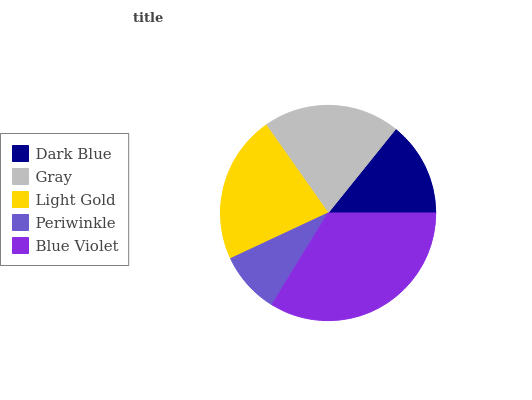Is Periwinkle the minimum?
Answer yes or no. Yes. Is Blue Violet the maximum?
Answer yes or no. Yes. Is Gray the minimum?
Answer yes or no. No. Is Gray the maximum?
Answer yes or no. No. Is Gray greater than Dark Blue?
Answer yes or no. Yes. Is Dark Blue less than Gray?
Answer yes or no. Yes. Is Dark Blue greater than Gray?
Answer yes or no. No. Is Gray less than Dark Blue?
Answer yes or no. No. Is Gray the high median?
Answer yes or no. Yes. Is Gray the low median?
Answer yes or no. Yes. Is Periwinkle the high median?
Answer yes or no. No. Is Dark Blue the low median?
Answer yes or no. No. 